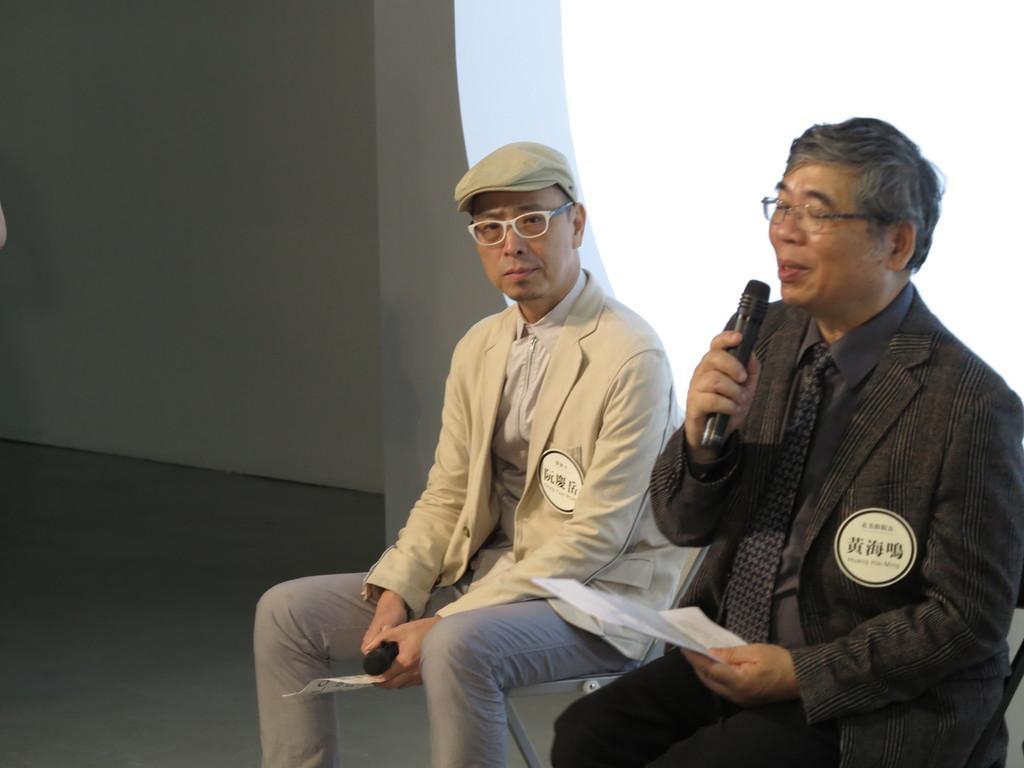Could you give a brief overview of what you see in this image? In this image we can see two persons sitting on the chairs and holding the objects, also we can see the wall and the sky. 